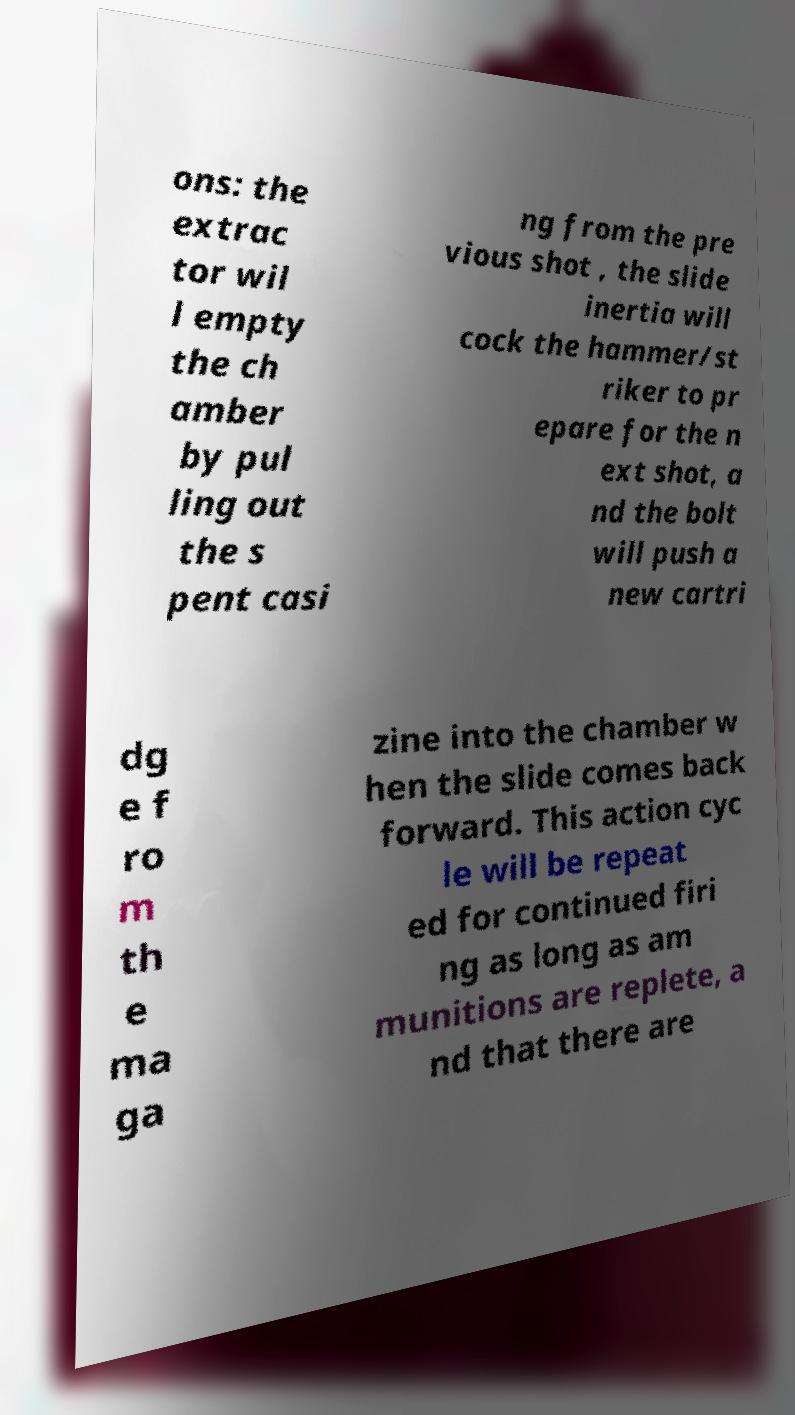For documentation purposes, I need the text within this image transcribed. Could you provide that? ons: the extrac tor wil l empty the ch amber by pul ling out the s pent casi ng from the pre vious shot , the slide inertia will cock the hammer/st riker to pr epare for the n ext shot, a nd the bolt will push a new cartri dg e f ro m th e ma ga zine into the chamber w hen the slide comes back forward. This action cyc le will be repeat ed for continued firi ng as long as am munitions are replete, a nd that there are 